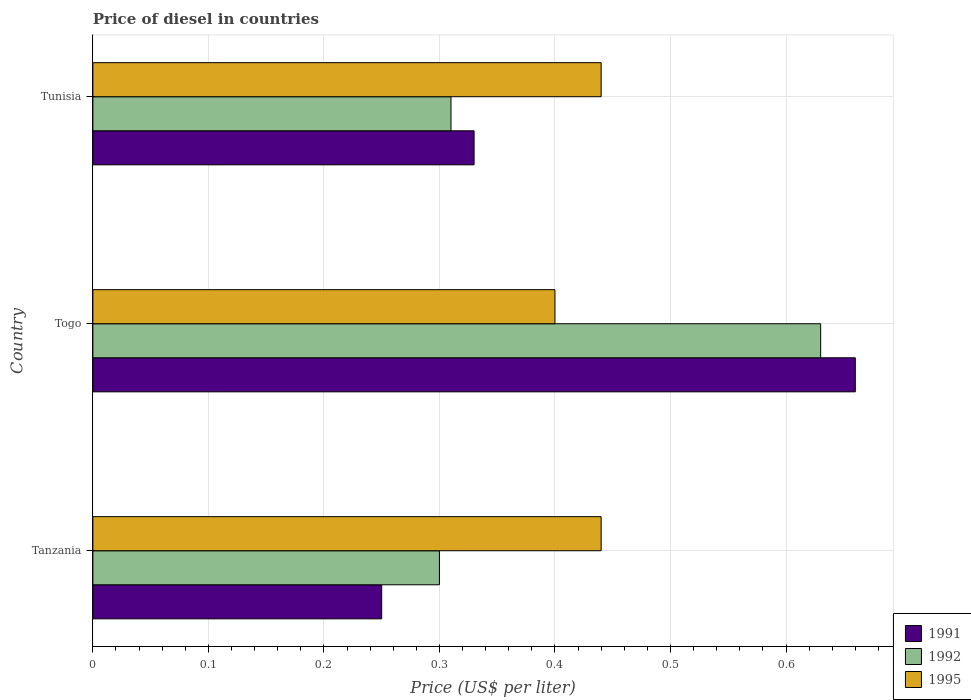How many groups of bars are there?
Your response must be concise. 3. How many bars are there on the 2nd tick from the bottom?
Ensure brevity in your answer.  3. What is the label of the 1st group of bars from the top?
Provide a succinct answer. Tunisia. Across all countries, what is the maximum price of diesel in 1992?
Provide a succinct answer. 0.63. Across all countries, what is the minimum price of diesel in 1991?
Keep it short and to the point. 0.25. In which country was the price of diesel in 1991 maximum?
Keep it short and to the point. Togo. In which country was the price of diesel in 1995 minimum?
Offer a very short reply. Togo. What is the total price of diesel in 1995 in the graph?
Provide a succinct answer. 1.28. What is the difference between the price of diesel in 1991 in Tanzania and that in Tunisia?
Your response must be concise. -0.08. What is the difference between the price of diesel in 1992 in Togo and the price of diesel in 1991 in Tanzania?
Your answer should be very brief. 0.38. What is the average price of diesel in 1991 per country?
Provide a short and direct response. 0.41. What is the difference between the price of diesel in 1992 and price of diesel in 1995 in Togo?
Ensure brevity in your answer.  0.23. In how many countries, is the price of diesel in 1995 greater than 0.58 US$?
Your answer should be compact. 0. What is the ratio of the price of diesel in 1992 in Tanzania to that in Tunisia?
Give a very brief answer. 0.97. What is the difference between the highest and the second highest price of diesel in 1992?
Make the answer very short. 0.32. What is the difference between the highest and the lowest price of diesel in 1991?
Your response must be concise. 0.41. In how many countries, is the price of diesel in 1992 greater than the average price of diesel in 1992 taken over all countries?
Your answer should be very brief. 1. Is the sum of the price of diesel in 1992 in Togo and Tunisia greater than the maximum price of diesel in 1995 across all countries?
Make the answer very short. Yes. What does the 1st bar from the top in Tunisia represents?
Your answer should be very brief. 1995. What does the 1st bar from the bottom in Tanzania represents?
Your answer should be very brief. 1991. How many bars are there?
Provide a short and direct response. 9. How many countries are there in the graph?
Provide a succinct answer. 3. Does the graph contain any zero values?
Provide a succinct answer. No. Does the graph contain grids?
Give a very brief answer. Yes. How many legend labels are there?
Provide a short and direct response. 3. What is the title of the graph?
Provide a short and direct response. Price of diesel in countries. Does "1965" appear as one of the legend labels in the graph?
Provide a succinct answer. No. What is the label or title of the X-axis?
Provide a succinct answer. Price (US$ per liter). What is the Price (US$ per liter) of 1991 in Tanzania?
Your answer should be very brief. 0.25. What is the Price (US$ per liter) of 1995 in Tanzania?
Offer a very short reply. 0.44. What is the Price (US$ per liter) in 1991 in Togo?
Provide a succinct answer. 0.66. What is the Price (US$ per liter) of 1992 in Togo?
Provide a short and direct response. 0.63. What is the Price (US$ per liter) of 1991 in Tunisia?
Your answer should be very brief. 0.33. What is the Price (US$ per liter) of 1992 in Tunisia?
Make the answer very short. 0.31. What is the Price (US$ per liter) in 1995 in Tunisia?
Provide a succinct answer. 0.44. Across all countries, what is the maximum Price (US$ per liter) of 1991?
Offer a very short reply. 0.66. Across all countries, what is the maximum Price (US$ per liter) in 1992?
Provide a succinct answer. 0.63. Across all countries, what is the maximum Price (US$ per liter) in 1995?
Keep it short and to the point. 0.44. Across all countries, what is the minimum Price (US$ per liter) of 1991?
Your answer should be compact. 0.25. Across all countries, what is the minimum Price (US$ per liter) of 1992?
Keep it short and to the point. 0.3. Across all countries, what is the minimum Price (US$ per liter) in 1995?
Make the answer very short. 0.4. What is the total Price (US$ per liter) of 1991 in the graph?
Provide a succinct answer. 1.24. What is the total Price (US$ per liter) in 1992 in the graph?
Provide a succinct answer. 1.24. What is the total Price (US$ per liter) of 1995 in the graph?
Provide a short and direct response. 1.28. What is the difference between the Price (US$ per liter) in 1991 in Tanzania and that in Togo?
Your answer should be very brief. -0.41. What is the difference between the Price (US$ per liter) of 1992 in Tanzania and that in Togo?
Your answer should be compact. -0.33. What is the difference between the Price (US$ per liter) of 1995 in Tanzania and that in Togo?
Offer a terse response. 0.04. What is the difference between the Price (US$ per liter) in 1991 in Tanzania and that in Tunisia?
Keep it short and to the point. -0.08. What is the difference between the Price (US$ per liter) in 1992 in Tanzania and that in Tunisia?
Your answer should be compact. -0.01. What is the difference between the Price (US$ per liter) of 1991 in Togo and that in Tunisia?
Ensure brevity in your answer.  0.33. What is the difference between the Price (US$ per liter) of 1992 in Togo and that in Tunisia?
Offer a very short reply. 0.32. What is the difference between the Price (US$ per liter) of 1995 in Togo and that in Tunisia?
Give a very brief answer. -0.04. What is the difference between the Price (US$ per liter) in 1991 in Tanzania and the Price (US$ per liter) in 1992 in Togo?
Keep it short and to the point. -0.38. What is the difference between the Price (US$ per liter) in 1991 in Tanzania and the Price (US$ per liter) in 1995 in Togo?
Provide a succinct answer. -0.15. What is the difference between the Price (US$ per liter) in 1991 in Tanzania and the Price (US$ per liter) in 1992 in Tunisia?
Offer a very short reply. -0.06. What is the difference between the Price (US$ per liter) of 1991 in Tanzania and the Price (US$ per liter) of 1995 in Tunisia?
Give a very brief answer. -0.19. What is the difference between the Price (US$ per liter) of 1992 in Tanzania and the Price (US$ per liter) of 1995 in Tunisia?
Your answer should be very brief. -0.14. What is the difference between the Price (US$ per liter) in 1991 in Togo and the Price (US$ per liter) in 1995 in Tunisia?
Give a very brief answer. 0.22. What is the difference between the Price (US$ per liter) in 1992 in Togo and the Price (US$ per liter) in 1995 in Tunisia?
Make the answer very short. 0.19. What is the average Price (US$ per liter) in 1991 per country?
Give a very brief answer. 0.41. What is the average Price (US$ per liter) in 1992 per country?
Keep it short and to the point. 0.41. What is the average Price (US$ per liter) of 1995 per country?
Ensure brevity in your answer.  0.43. What is the difference between the Price (US$ per liter) of 1991 and Price (US$ per liter) of 1992 in Tanzania?
Keep it short and to the point. -0.05. What is the difference between the Price (US$ per liter) of 1991 and Price (US$ per liter) of 1995 in Tanzania?
Ensure brevity in your answer.  -0.19. What is the difference between the Price (US$ per liter) of 1992 and Price (US$ per liter) of 1995 in Tanzania?
Ensure brevity in your answer.  -0.14. What is the difference between the Price (US$ per liter) in 1991 and Price (US$ per liter) in 1995 in Togo?
Your answer should be compact. 0.26. What is the difference between the Price (US$ per liter) of 1992 and Price (US$ per liter) of 1995 in Togo?
Your response must be concise. 0.23. What is the difference between the Price (US$ per liter) in 1991 and Price (US$ per liter) in 1995 in Tunisia?
Offer a terse response. -0.11. What is the difference between the Price (US$ per liter) in 1992 and Price (US$ per liter) in 1995 in Tunisia?
Provide a succinct answer. -0.13. What is the ratio of the Price (US$ per liter) in 1991 in Tanzania to that in Togo?
Offer a very short reply. 0.38. What is the ratio of the Price (US$ per liter) of 1992 in Tanzania to that in Togo?
Make the answer very short. 0.48. What is the ratio of the Price (US$ per liter) in 1995 in Tanzania to that in Togo?
Keep it short and to the point. 1.1. What is the ratio of the Price (US$ per liter) in 1991 in Tanzania to that in Tunisia?
Offer a terse response. 0.76. What is the ratio of the Price (US$ per liter) of 1995 in Tanzania to that in Tunisia?
Make the answer very short. 1. What is the ratio of the Price (US$ per liter) of 1991 in Togo to that in Tunisia?
Offer a very short reply. 2. What is the ratio of the Price (US$ per liter) of 1992 in Togo to that in Tunisia?
Your answer should be very brief. 2.03. What is the ratio of the Price (US$ per liter) in 1995 in Togo to that in Tunisia?
Offer a very short reply. 0.91. What is the difference between the highest and the second highest Price (US$ per liter) of 1991?
Your response must be concise. 0.33. What is the difference between the highest and the second highest Price (US$ per liter) in 1992?
Provide a succinct answer. 0.32. What is the difference between the highest and the second highest Price (US$ per liter) in 1995?
Ensure brevity in your answer.  0. What is the difference between the highest and the lowest Price (US$ per liter) in 1991?
Offer a terse response. 0.41. What is the difference between the highest and the lowest Price (US$ per liter) in 1992?
Make the answer very short. 0.33. What is the difference between the highest and the lowest Price (US$ per liter) in 1995?
Offer a very short reply. 0.04. 